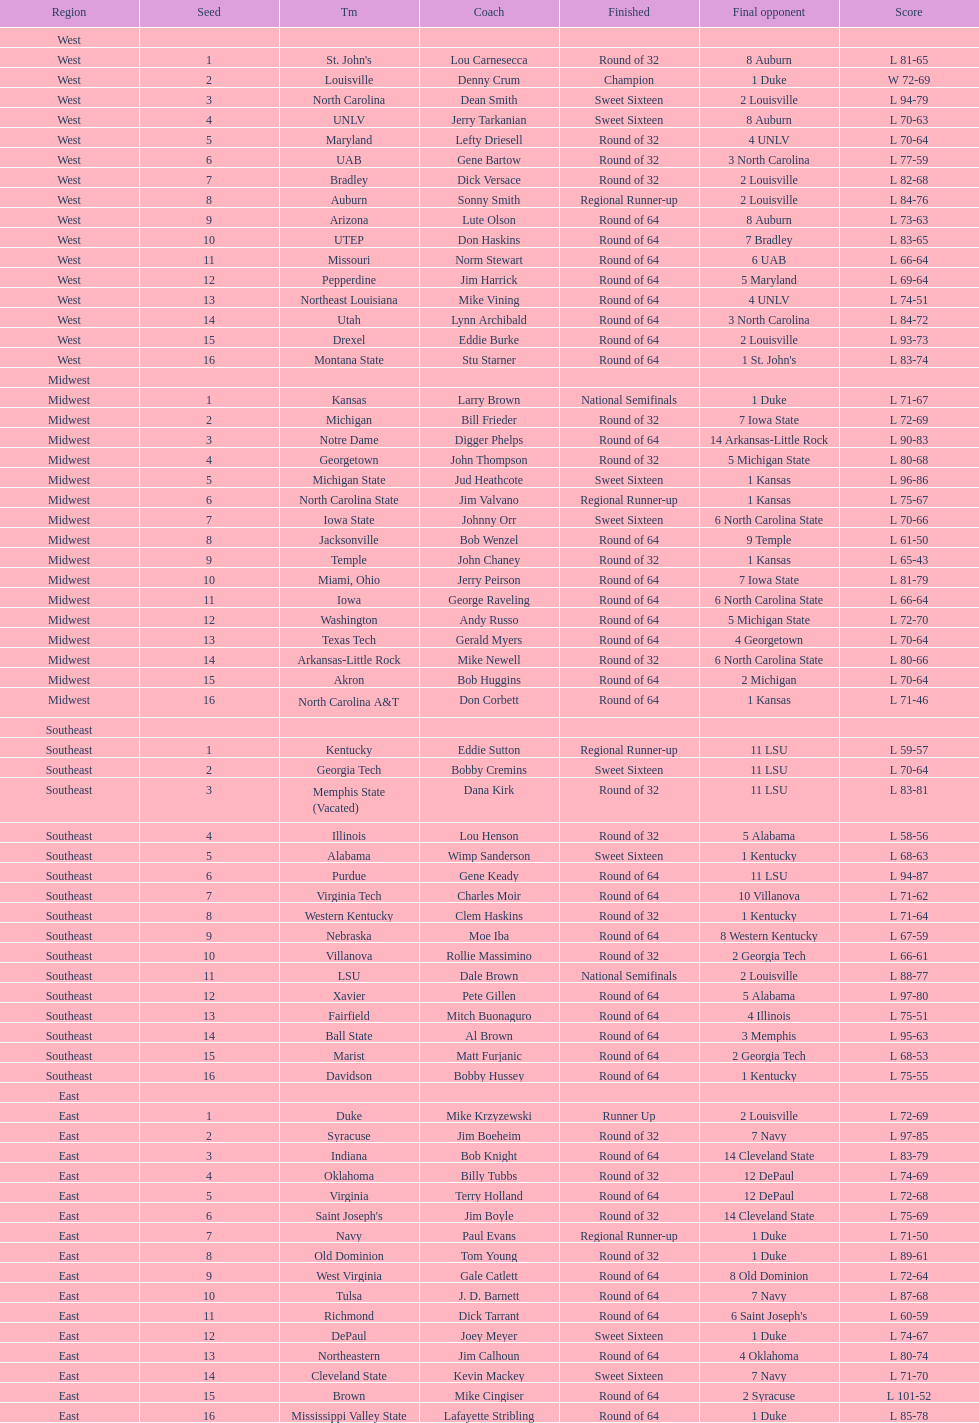What team finished at the top of all else and was finished as champions? Louisville. 